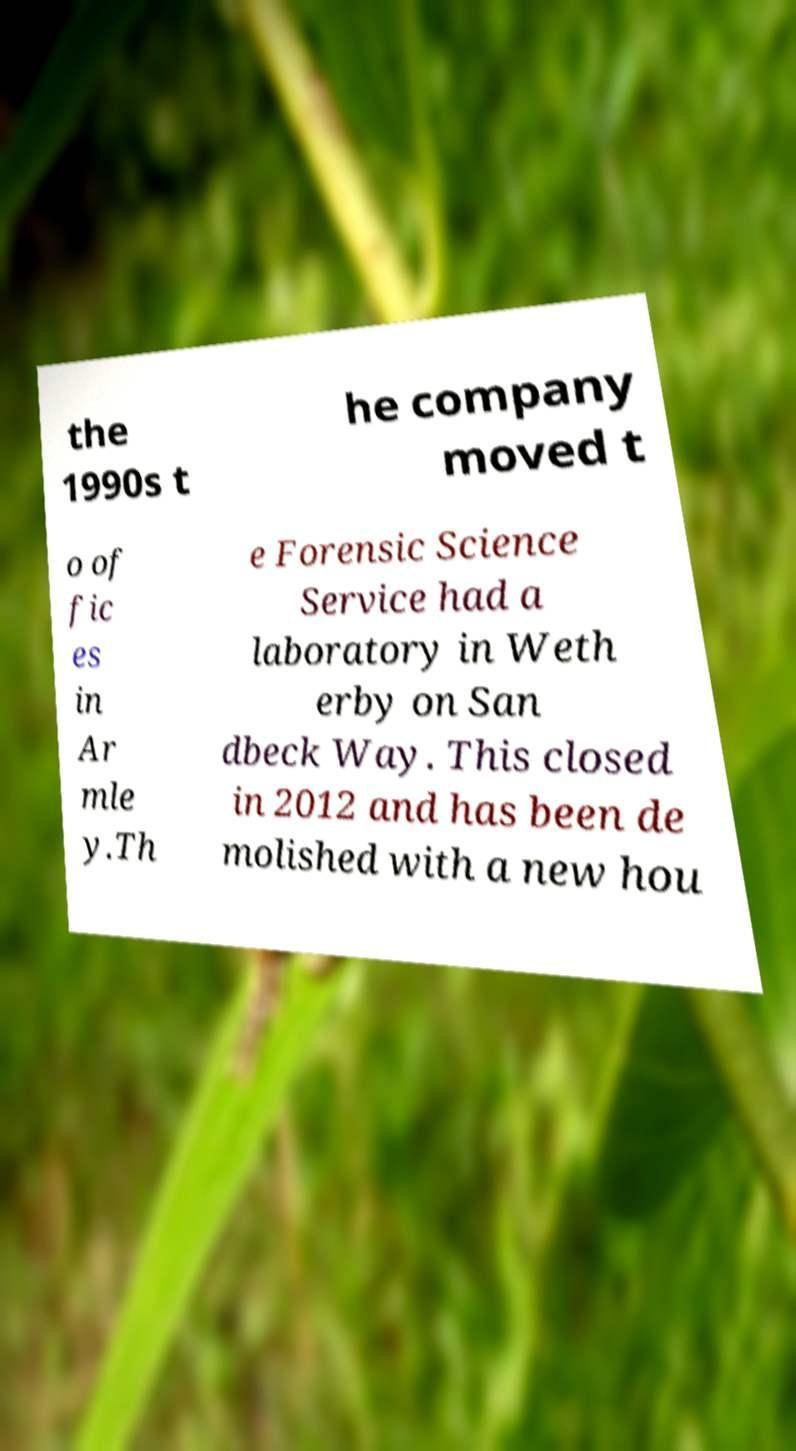Please identify and transcribe the text found in this image. the 1990s t he company moved t o of fic es in Ar mle y.Th e Forensic Science Service had a laboratory in Weth erby on San dbeck Way. This closed in 2012 and has been de molished with a new hou 